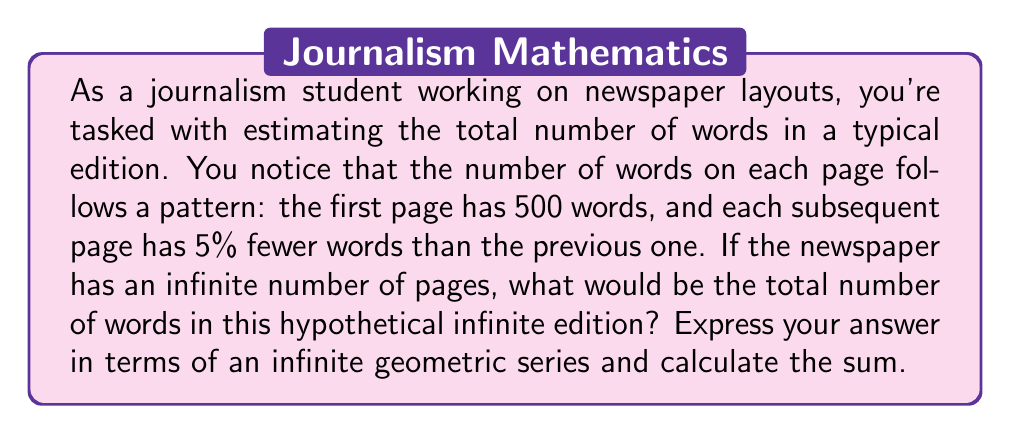What is the answer to this math problem? Let's approach this step-by-step:

1) First, we need to identify the geometric sequence:
   - First term (a): 500 words
   - Common ratio (r): 0.95 (95% of the previous page)

2) The sequence of words per page would be:
   500, 500(0.95), 500(0.95)², 500(0.95)³, ...

3) The sum of an infinite geometric series is given by the formula:
   
   $$ S_{\infty} = \frac{a}{1-r} $$

   Where $a$ is the first term and $r$ is the common ratio.

4) In this case:
   $a = 500$
   $r = 0.95$

5) Substituting these values into the formula:

   $$ S_{\infty} = \frac{500}{1-0.95} = \frac{500}{0.05} $$

6) Simplifying:

   $$ S_{\infty} = 10,000 $$

Therefore, the sum of this infinite series is 10,000 words.
Answer: The total number of words in the hypothetical infinite edition of the newspaper would be 10,000 words. 